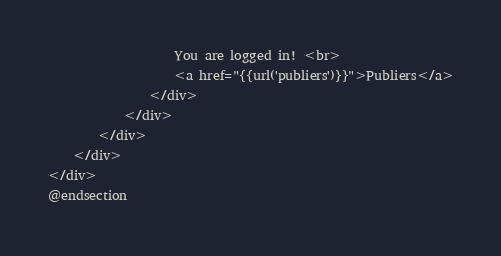Convert code to text. <code><loc_0><loc_0><loc_500><loc_500><_PHP_>
                    You are logged in! <br>
                    <a href="{{url('publiers')}}">Publiers</a>
                </div>
            </div>
        </div>
    </div>
</div>
@endsection
</code> 